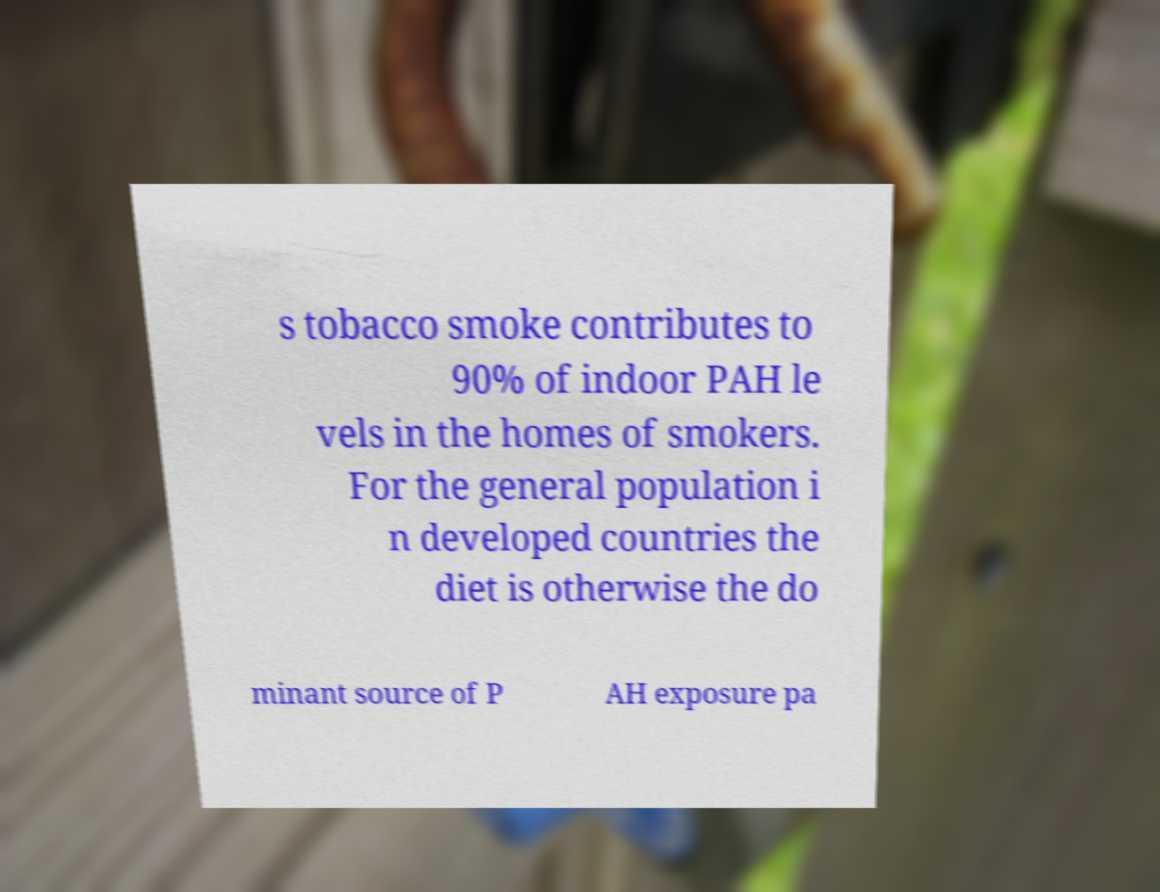There's text embedded in this image that I need extracted. Can you transcribe it verbatim? s tobacco smoke contributes to 90% of indoor PAH le vels in the homes of smokers. For the general population i n developed countries the diet is otherwise the do minant source of P AH exposure pa 